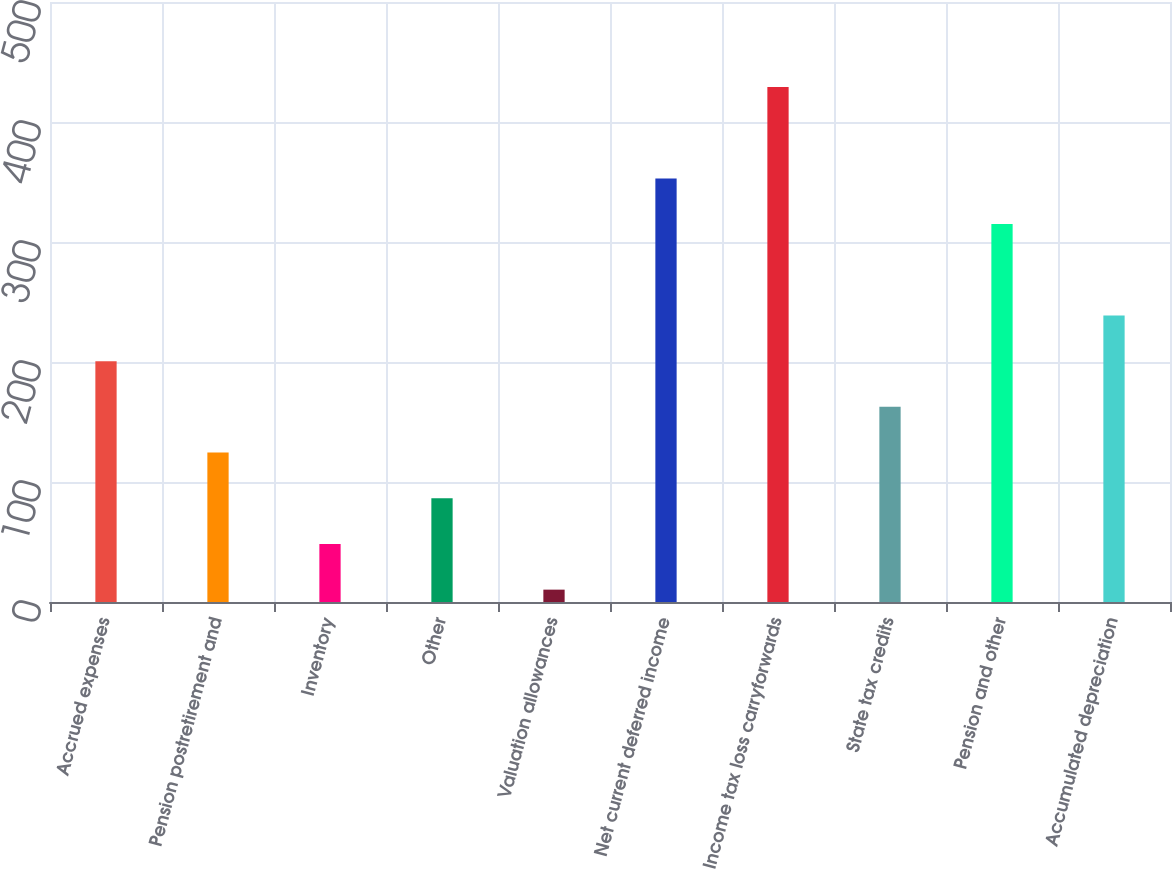Convert chart. <chart><loc_0><loc_0><loc_500><loc_500><bar_chart><fcel>Accrued expenses<fcel>Pension postretirement and<fcel>Inventory<fcel>Other<fcel>Valuation allowances<fcel>Net current deferred income<fcel>Income tax loss carryforwards<fcel>State tax credits<fcel>Pension and other<fcel>Accumulated depreciation<nl><fcel>200.7<fcel>124.54<fcel>48.38<fcel>86.46<fcel>10.3<fcel>353.02<fcel>429.18<fcel>162.62<fcel>314.94<fcel>238.78<nl></chart> 